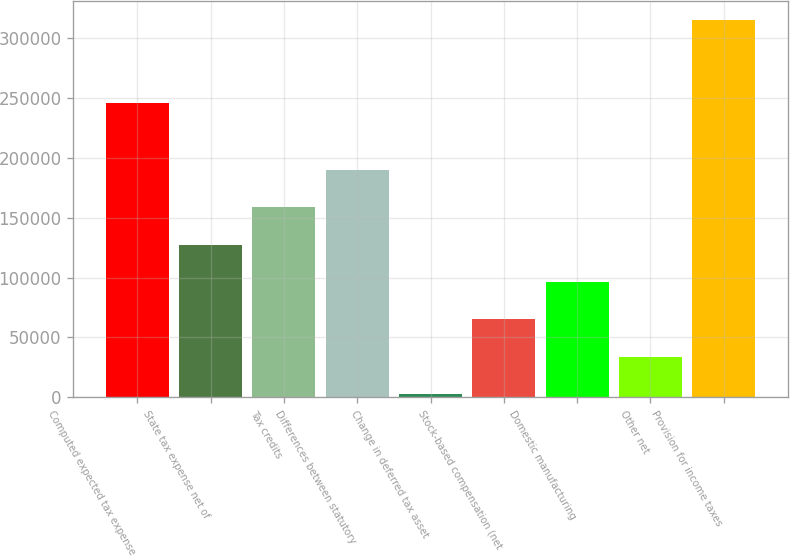Convert chart. <chart><loc_0><loc_0><loc_500><loc_500><bar_chart><fcel>Computed expected tax expense<fcel>State tax expense net of<fcel>Tax credits<fcel>Differences between statutory<fcel>Change in deferred tax asset<fcel>Stock-based compensation (net<fcel>Domestic manufacturing<fcel>Other net<fcel>Provision for income taxes<nl><fcel>245532<fcel>127660<fcel>158886<fcel>190111<fcel>2759<fcel>65209.6<fcel>96434.9<fcel>33984.3<fcel>315012<nl></chart> 